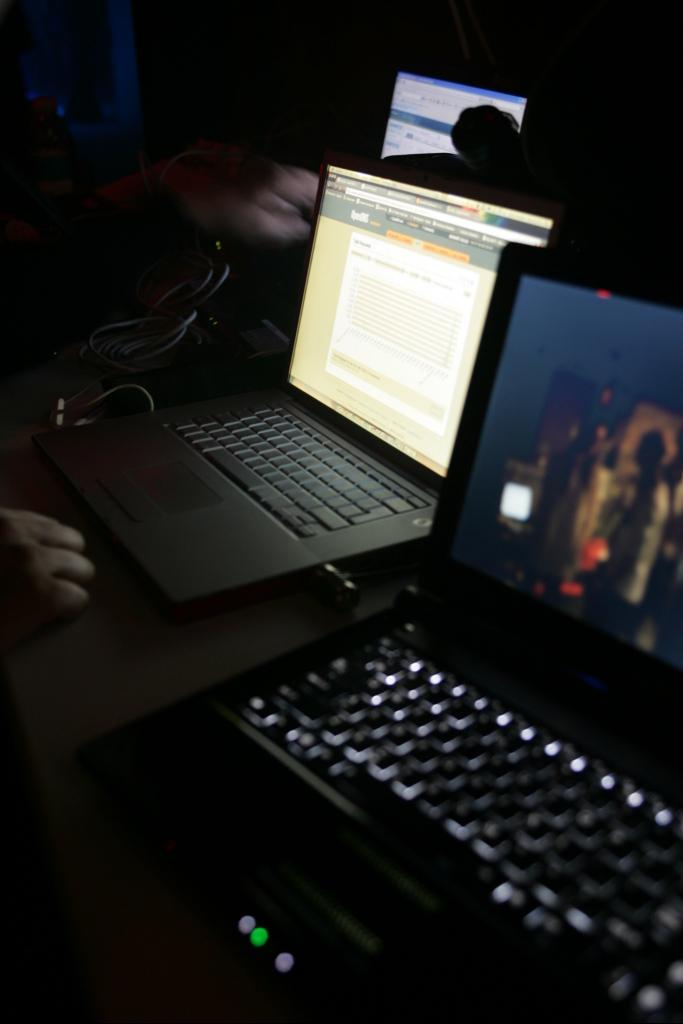How many laptops are present in the image? There are two laptops in the image. What else can be seen on the left side of the image? A human hand is visible on the left side of the image. What is located in the background of the image? There is a monitor screen in the background of the image. What type of dirt can be seen on the scissors in the image? There are no scissors present in the image, so it is not possible to determine what type of dirt might be on them. What is the relation between the two laptops in the image? The provided facts do not give any information about the relationship between the two laptops, so it is not possible to determine their relation. 